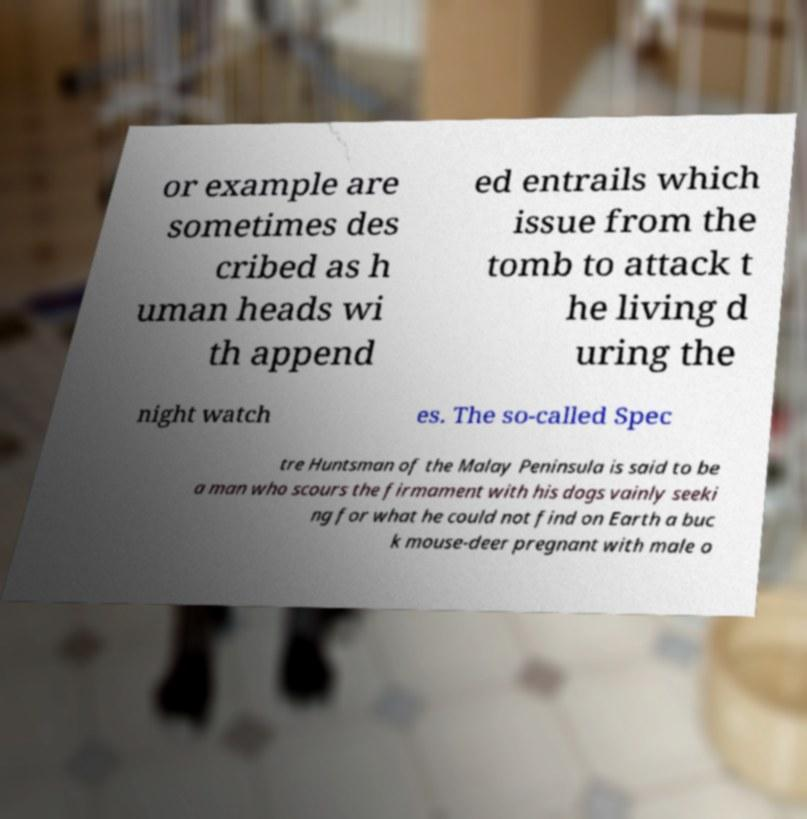Can you accurately transcribe the text from the provided image for me? or example are sometimes des cribed as h uman heads wi th append ed entrails which issue from the tomb to attack t he living d uring the night watch es. The so-called Spec tre Huntsman of the Malay Peninsula is said to be a man who scours the firmament with his dogs vainly seeki ng for what he could not find on Earth a buc k mouse-deer pregnant with male o 